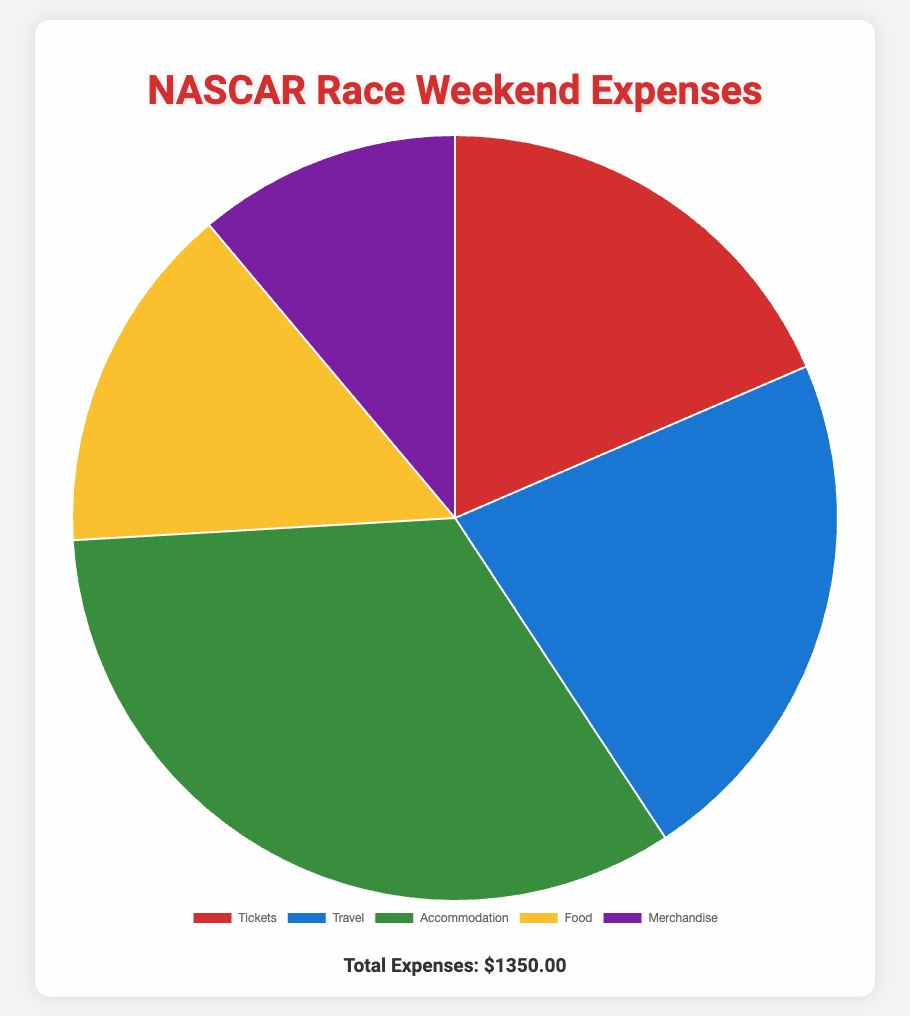Which expense category has the highest spending? To determine the category with the highest spending, we compare all the expense amounts: $250 for Tickets, $300 for Travel, $450 for Accommodation, $200 for Food, and $150 for Merchandise. The highest amount is $450 in Accommodation.
Answer: Accommodation What is the total amount spent on Tickets and Travel combined? Add the amounts spent on Tickets and Travel: $250 (Tickets) + $300 (Travel) = $550.
Answer: $550 Which expense is represented by the color red in the chart? Referring to the visual attributes of the pie chart, the color red represents the 'Tickets' category.
Answer: Tickets How much more is spent on Accommodation compared to Food? Subtract the amount spent on Food from the amount spent on Accommodation: $450 (Accommodation) - $200 (Food) = $250.
Answer: $250 What percentage of total expenses is spent on Merchandise? First, calculate the total expenses by summing all categories: $250 + $300 + $450 + $200 + $150 = $1350. Then, calculate the percentage for Merchandise: ($150 / $1350) * 100 ≈ 11.11%.
Answer: 11.11% Which expense category has the second lowest spending? Ordering the expense amounts from lowest to highest: $150 (Merchandise), $200 (Food), $250 (Tickets), $300 (Travel), and $450 (Accommodation). The second lowest amount is $200 for Food.
Answer: Food What is the difference between the highest and lowest expense categories? Identify the highest expense ($450 for Accommodation) and the lowest expense ($150 for Merchandise). Then subtract the lowest from the highest: $450 - $150 = $300.
Answer: $300 Which two categories together amount to more than half of the total expenses? Calculate half of the total expenses: $1350 / 2 = $675. The two highest expenses are Accommodation ($450) and Travel ($300). Adding these: $450 + $300 = $750, which is more than half of total expenses.
Answer: Accommodation and Travel 